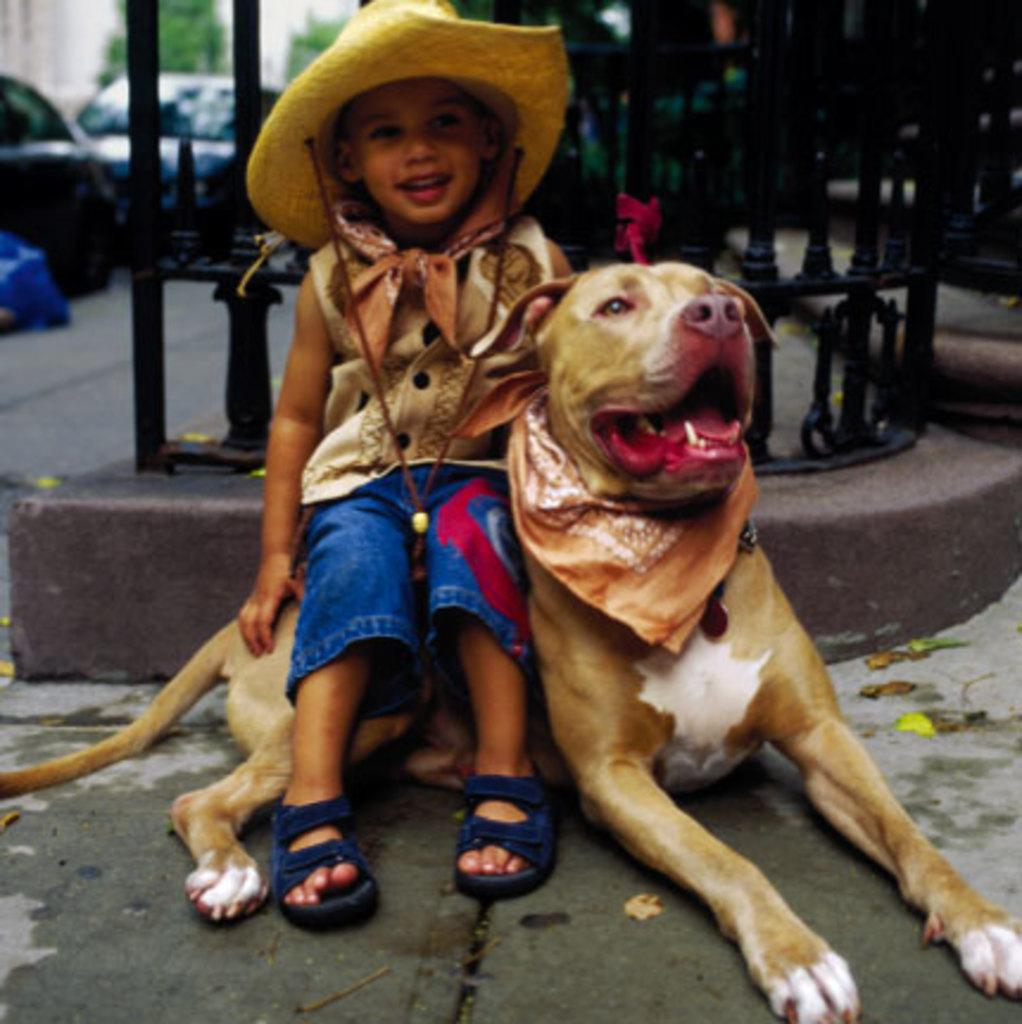What is the main subject of the image? The main subject of the image is a kid. What is the kid doing in the image? The kid is sitting on a dog. What is the kid wearing in the image? The kid is wearing a cap. What can be seen in the background of the image? There are vehicles visible in the background of the image, and the background is a road. What type of monkey can be seen interacting with the kid in the image? There is no monkey present in the image; the kid is sitting on a dog. What is the mass of the vehicles visible in the background of the image? The mass of the vehicles cannot be determined from the image alone, as it does not provide any information about their size or weight. 